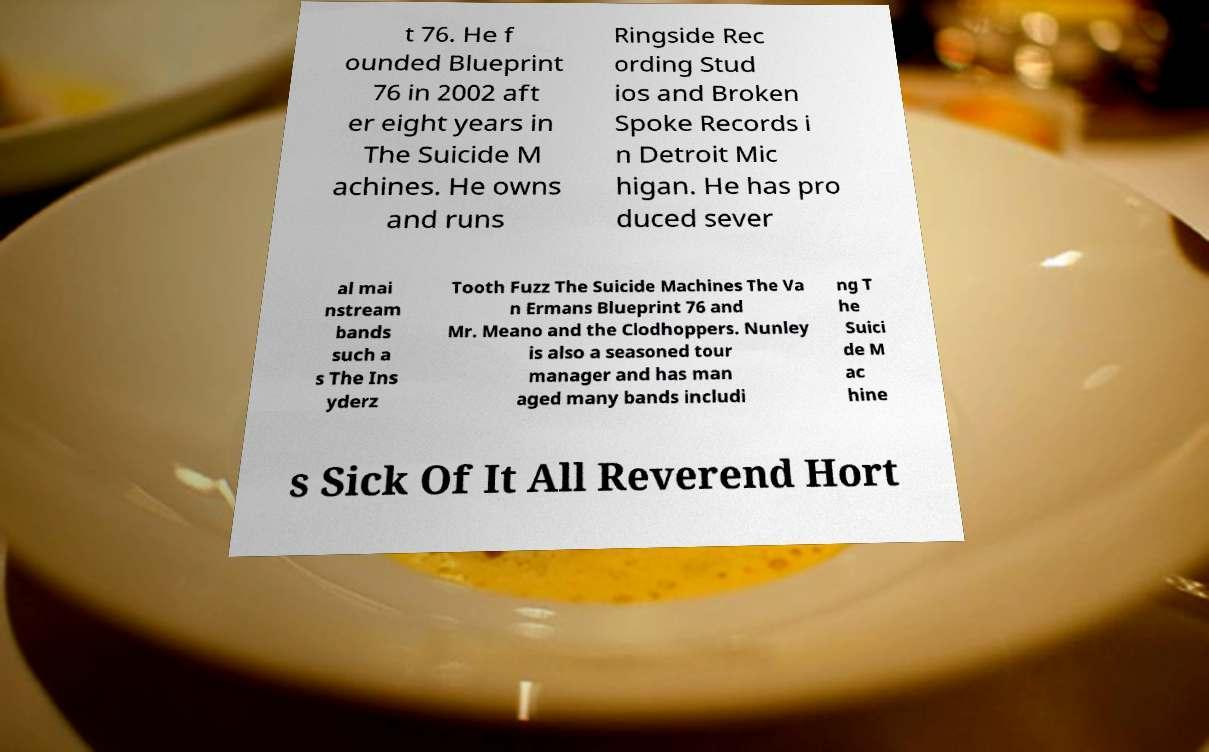There's text embedded in this image that I need extracted. Can you transcribe it verbatim? t 76. He f ounded Blueprint 76 in 2002 aft er eight years in The Suicide M achines. He owns and runs Ringside Rec ording Stud ios and Broken Spoke Records i n Detroit Mic higan. He has pro duced sever al mai nstream bands such a s The Ins yderz Tooth Fuzz The Suicide Machines The Va n Ermans Blueprint 76 and Mr. Meano and the Clodhoppers. Nunley is also a seasoned tour manager and has man aged many bands includi ng T he Suici de M ac hine s Sick Of It All Reverend Hort 